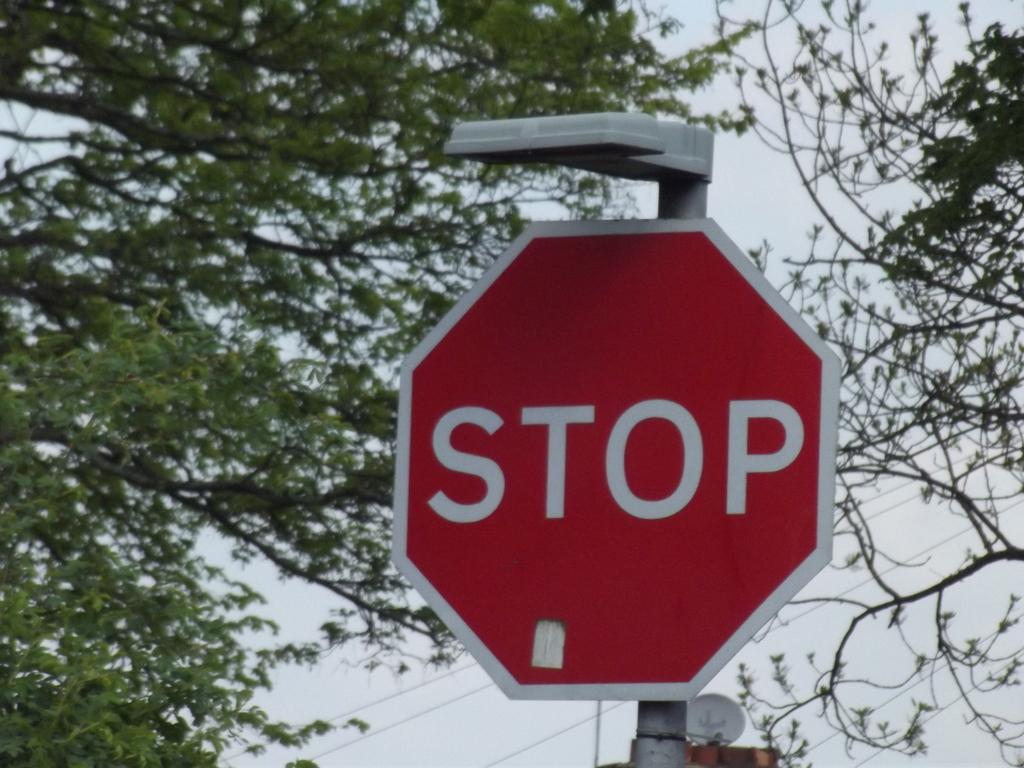What doe the sign say?
Make the answer very short. Stop. 